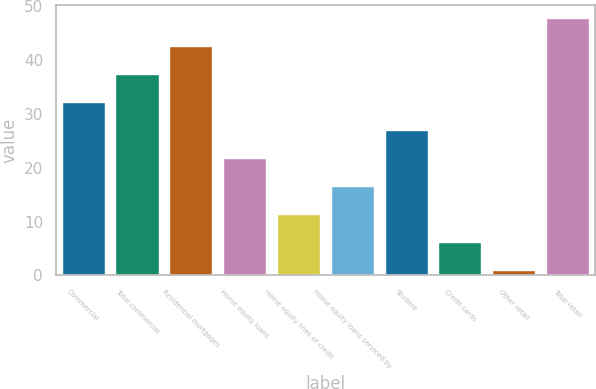<chart> <loc_0><loc_0><loc_500><loc_500><bar_chart><fcel>Commercial<fcel>Total commercial<fcel>Residential mortgages<fcel>Home equity loans<fcel>Home equity lines of credit<fcel>Home equity loans serviced by<fcel>Student<fcel>Credit cards<fcel>Other retail<fcel>Total retail<nl><fcel>32.2<fcel>37.4<fcel>42.6<fcel>21.8<fcel>11.4<fcel>16.6<fcel>27<fcel>6.2<fcel>1<fcel>47.8<nl></chart> 